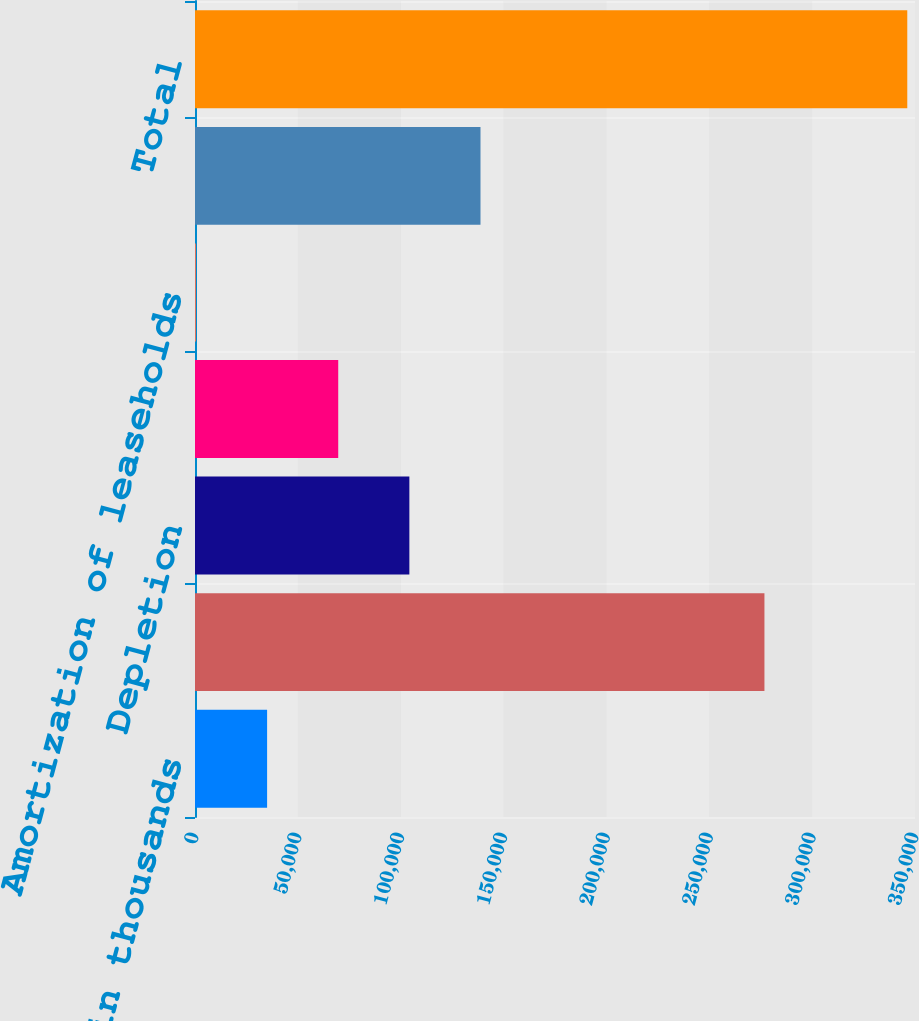<chart> <loc_0><loc_0><loc_500><loc_500><bar_chart><fcel>in thousands<fcel>Depreciation<fcel>Depletion<fcel>Accretion<fcel>Amortization of leaseholds<fcel>Amortization of intangibles<fcel>Total<nl><fcel>35049.4<fcel>276814<fcel>104204<fcel>69626.8<fcel>472<fcel>138782<fcel>346246<nl></chart> 